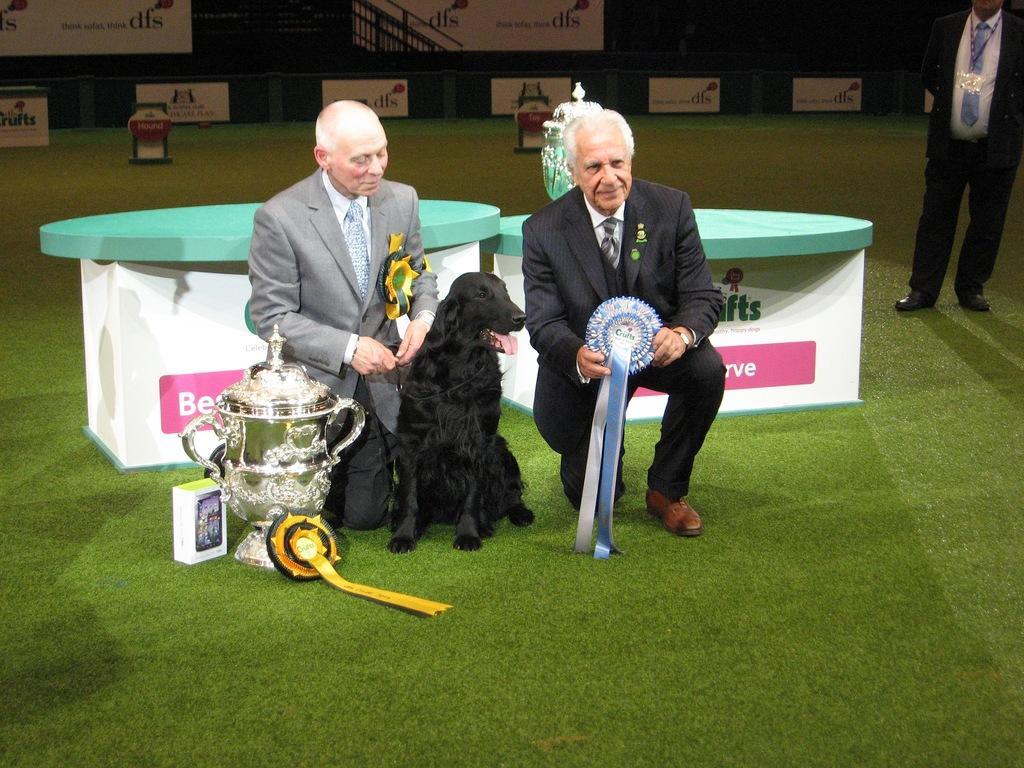Can you describe this image briefly? In the foreground of this image, there are two men squatting on the grass, where a man is holding a batch. We can also see a black dog, cup, batch and a box on the grass. Behind them, there are tables and a man standing on the right. In the background, there are banners and railing in the dark. 